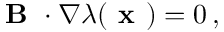Convert formula to latex. <formula><loc_0><loc_0><loc_500><loc_500>\begin{array} { r } { B \cdot \nabla \lambda ( x ) = 0 \, , } \end{array}</formula> 